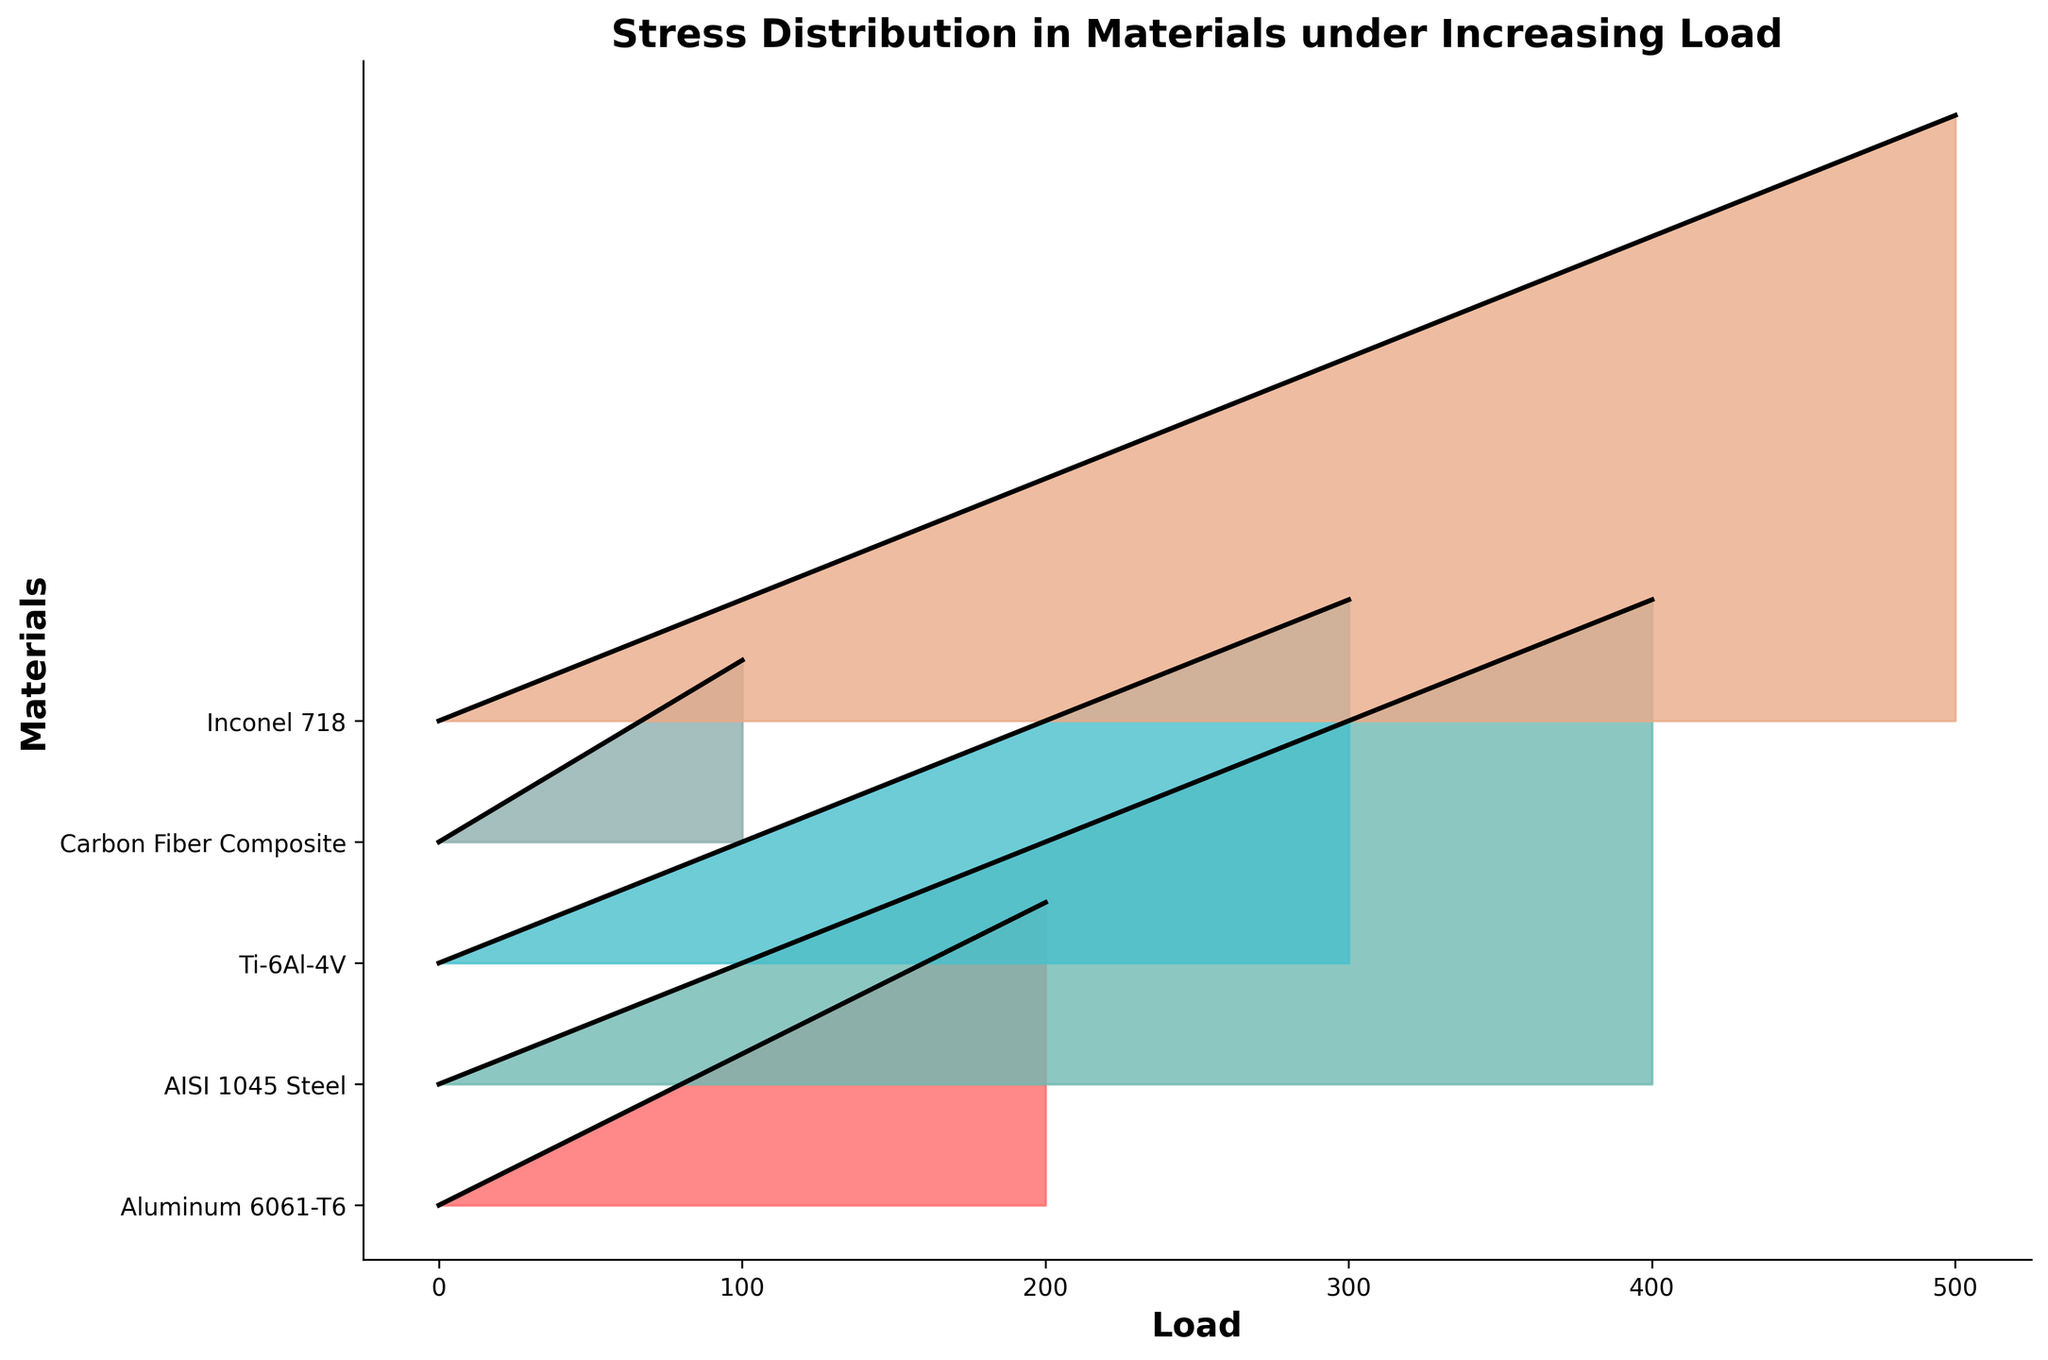What is the title of the plot? The title of the plot is written at the top center of the figure. By visually reading it, we can identify it.
Answer: Stress Distribution in Materials under Increasing Load How many materials are being compared in the plot? The plot lists the materials on the y-axis with labels. By counting those labels, we can determine the number of materials.
Answer: Five Which material experiences the highest stress under the maximum load? We need to look at the end of each line on the right side of the plot and see which line reaches the highest value on the y-axis.
Answer: Inconel 718 At what load does Carbon Fiber Composite reach a stress of 30? We trace the curve for Carbon Fiber Composite and see where it crosses the 30-stress mark on the y-axis.
Answer: Load of 50 Does AISI 1045 Steel have a higher stress than Aluminum 6061-T6 for a load of 200? We compare the stress values for both materials at the 200-load mark by looking at where their curves intersect the vertical line drawn at 200 load.
Answer: Yes What is the stress difference between Ti-6Al-4V and Aluminum 6061-T6 at a load of 150? Locate the stress values for both materials at 150 load on the plot and subtract the stress of Aluminum 6061-T6 from Ti-6Al-4V.
Answer: 15 How does the stress of Inconel 718 compare to Ti-6Al-4V at half the maximum load of Inconel 718? First, find half of the maximum load of Inconel 718 (which is 250), and compare the stress values of both materials at this load point.
Answer: Equal Which material has the steepest increase in stress initially (from load 0 to the first non-zero load)? By comparing the slopes of the initial segments of the curves for all materials, we can identify the one with the steepest slope.
Answer: Carbon Fiber Composite 